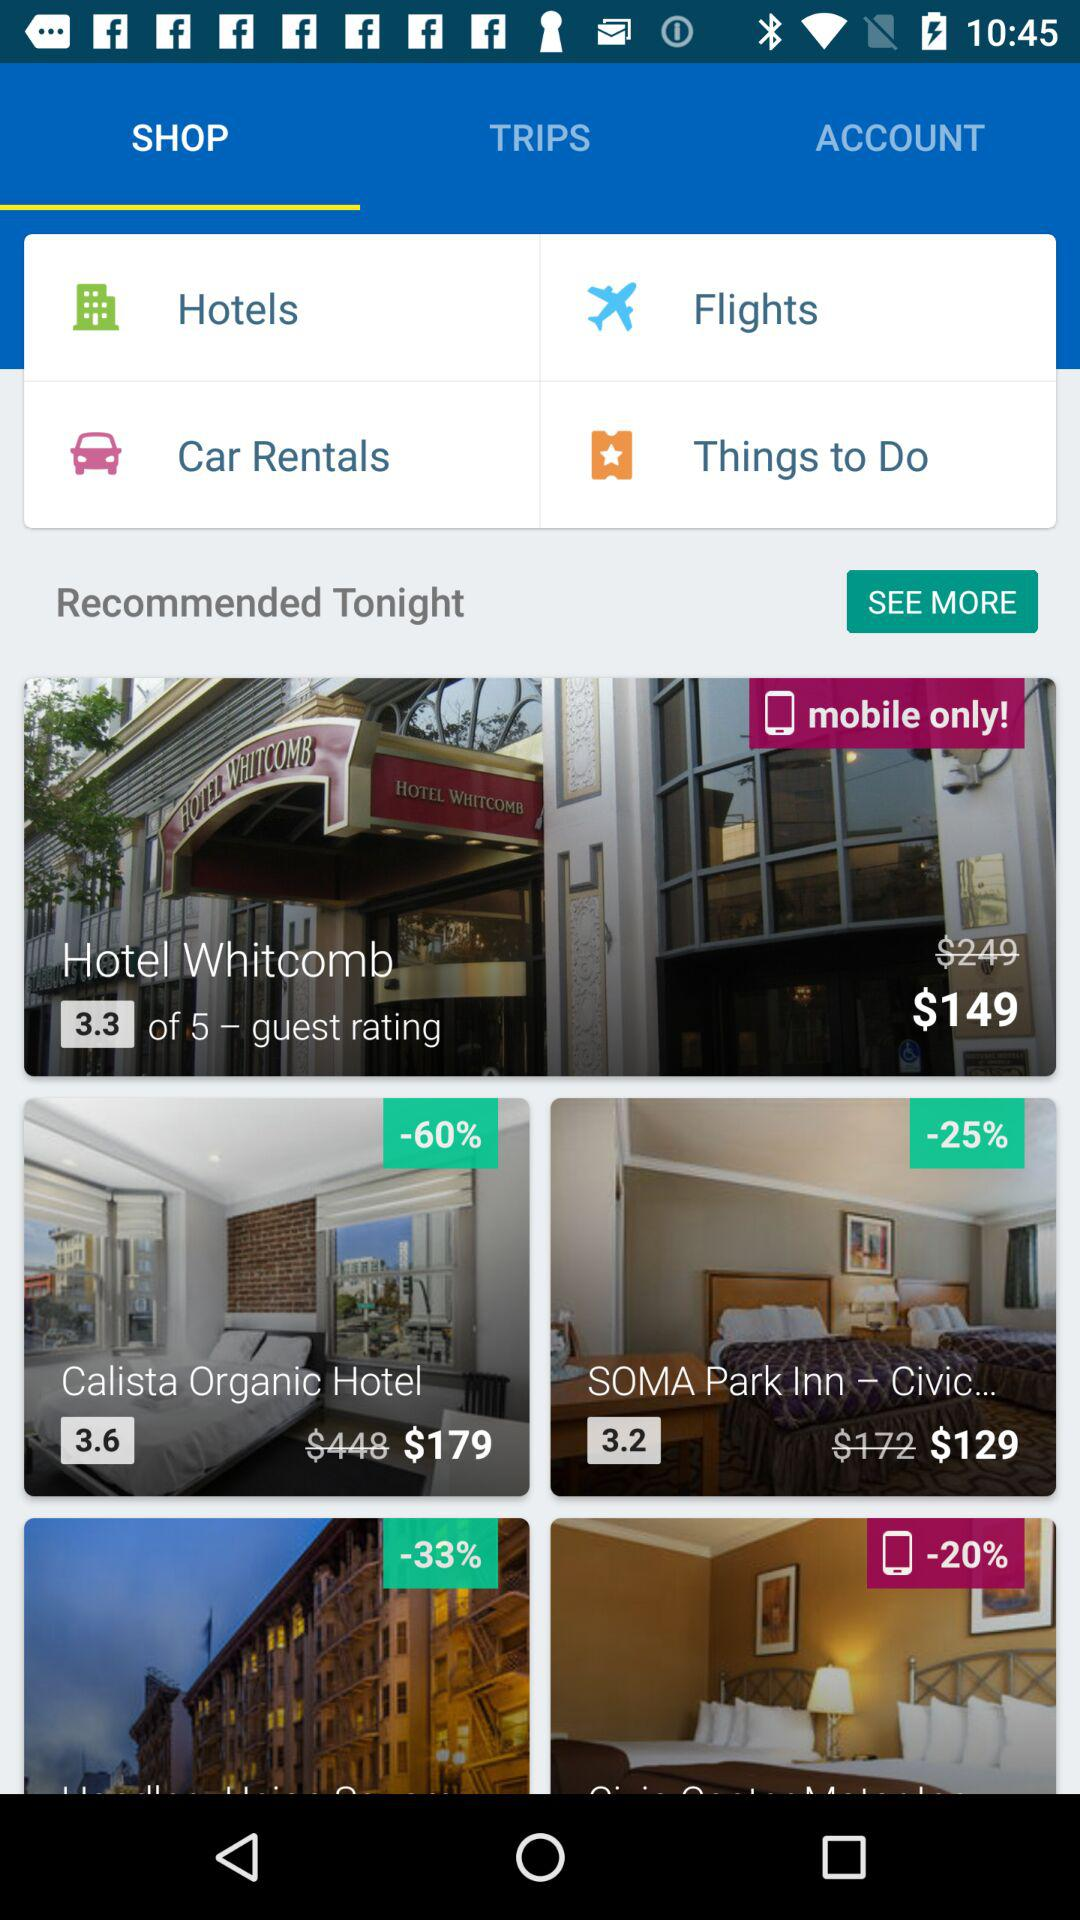What is the name of the hotel with a 3.3 rating out of 5? The name of the hotel is "Hotel Whitcomb". 